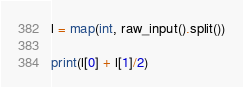Convert code to text. <code><loc_0><loc_0><loc_500><loc_500><_Python_>l = map(int, raw_input().split())

print(l[0] + l[1]/2)</code> 